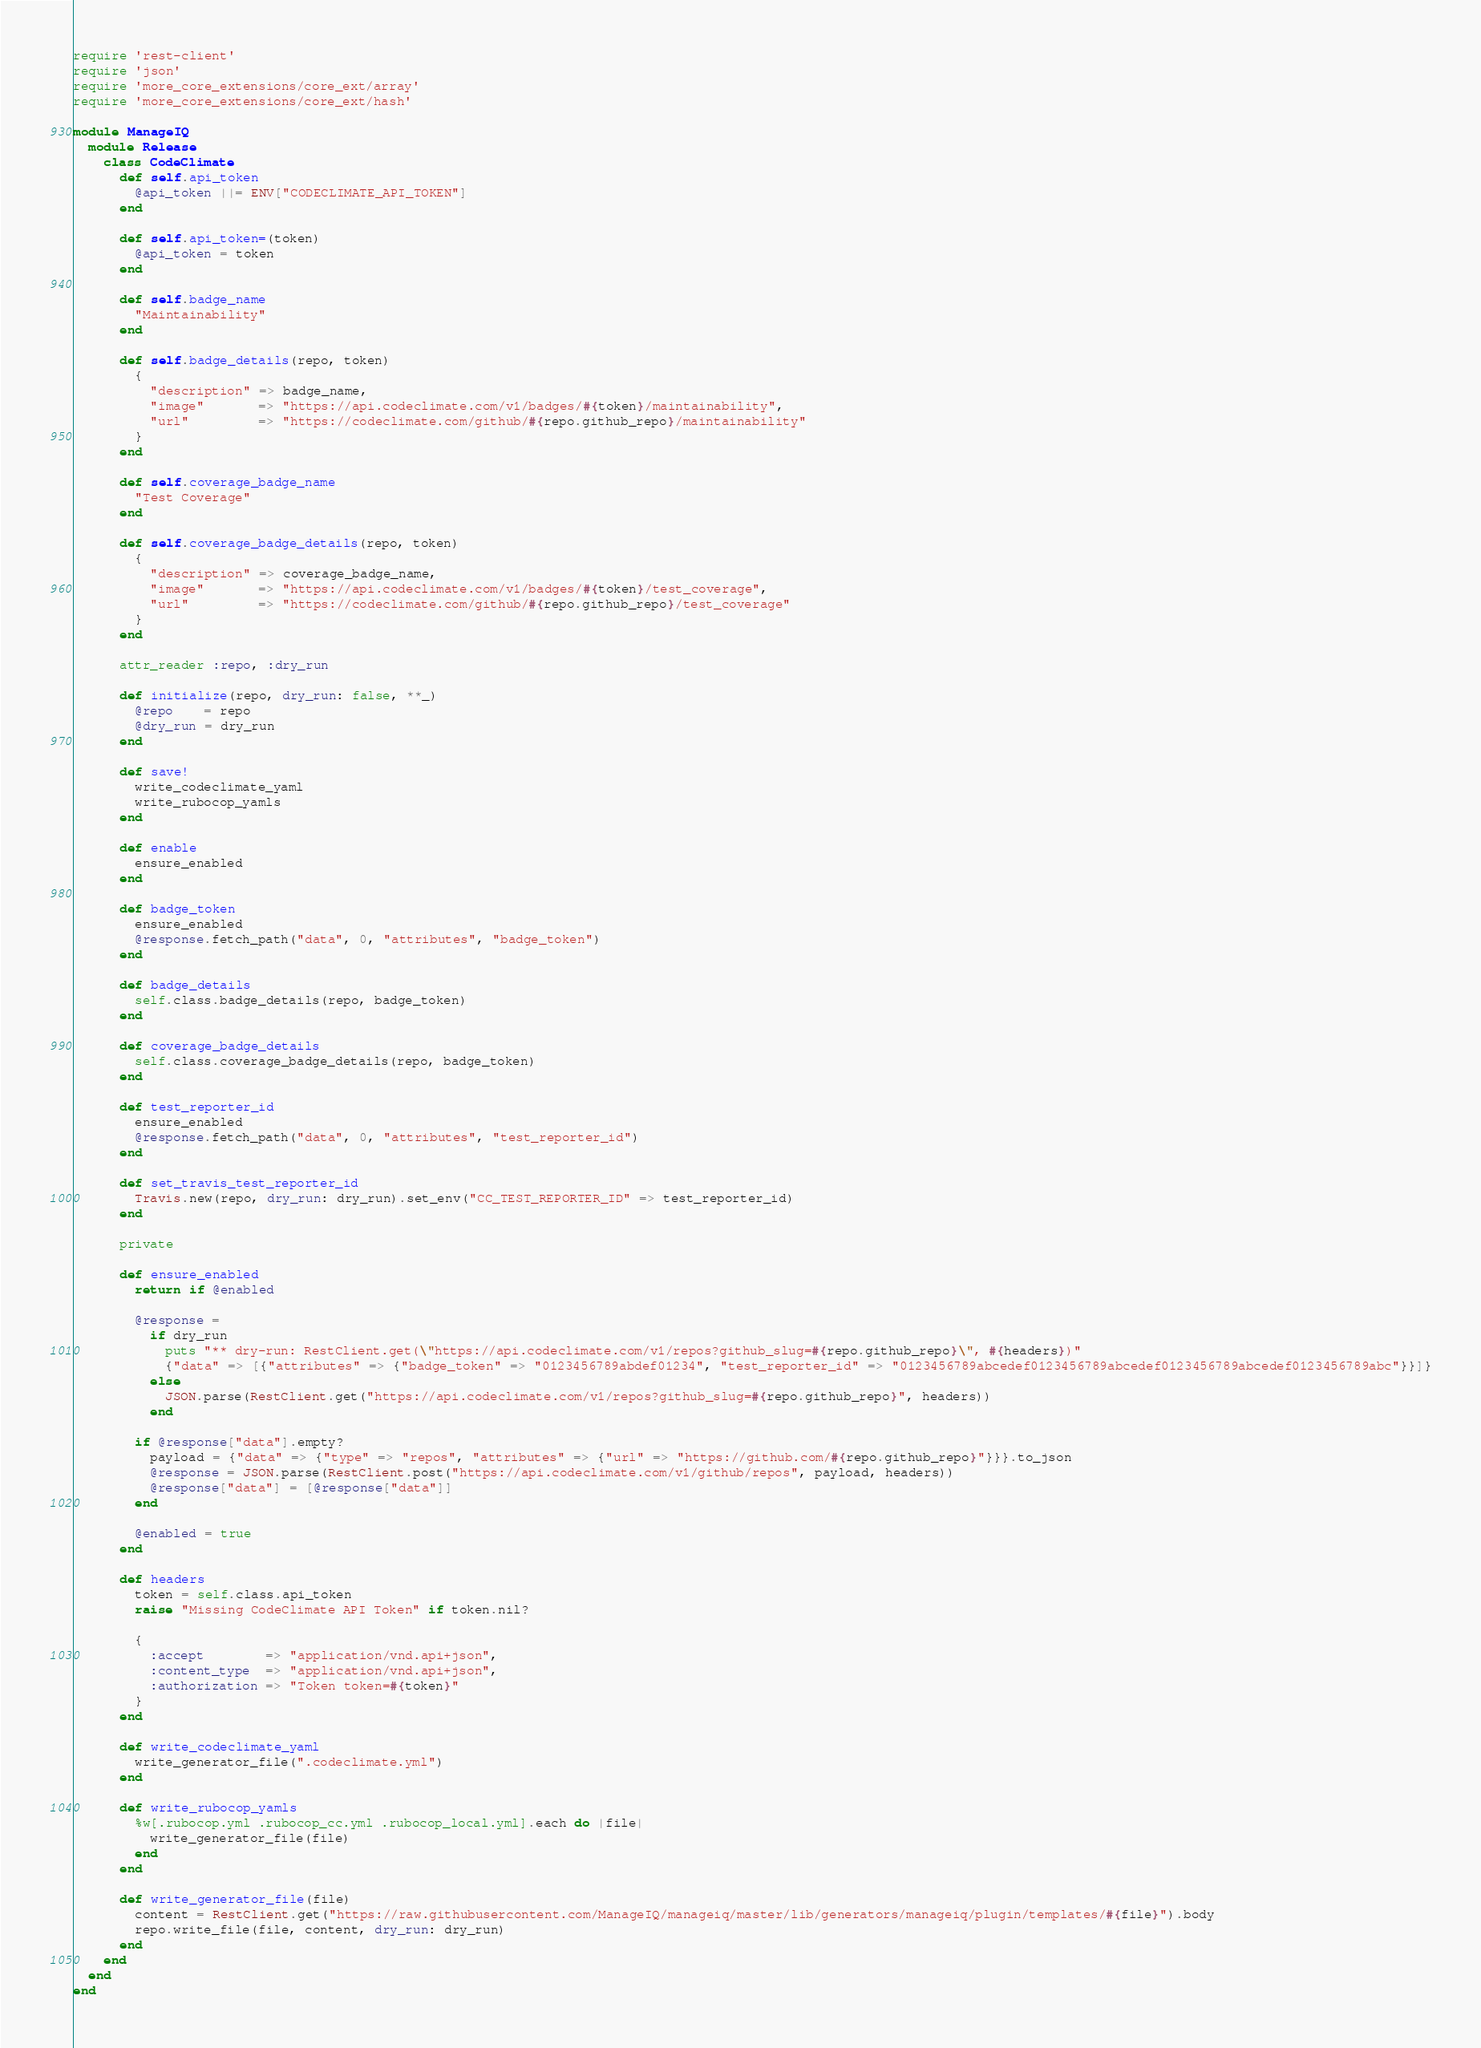Convert code to text. <code><loc_0><loc_0><loc_500><loc_500><_Ruby_>require 'rest-client'
require 'json'
require 'more_core_extensions/core_ext/array'
require 'more_core_extensions/core_ext/hash'

module ManageIQ
  module Release
    class CodeClimate
      def self.api_token
        @api_token ||= ENV["CODECLIMATE_API_TOKEN"]
      end

      def self.api_token=(token)
        @api_token = token
      end

      def self.badge_name
        "Maintainability"
      end

      def self.badge_details(repo, token)
        {
          "description" => badge_name,
          "image"       => "https://api.codeclimate.com/v1/badges/#{token}/maintainability",
          "url"         => "https://codeclimate.com/github/#{repo.github_repo}/maintainability"
        }
      end

      def self.coverage_badge_name
        "Test Coverage"
      end

      def self.coverage_badge_details(repo, token)
        {
          "description" => coverage_badge_name,
          "image"       => "https://api.codeclimate.com/v1/badges/#{token}/test_coverage",
          "url"         => "https://codeclimate.com/github/#{repo.github_repo}/test_coverage"
        }
      end

      attr_reader :repo, :dry_run

      def initialize(repo, dry_run: false, **_)
        @repo    = repo
        @dry_run = dry_run
      end

      def save!
        write_codeclimate_yaml
        write_rubocop_yamls
      end

      def enable
        ensure_enabled
      end

      def badge_token
        ensure_enabled
        @response.fetch_path("data", 0, "attributes", "badge_token")
      end

      def badge_details
        self.class.badge_details(repo, badge_token)
      end

      def coverage_badge_details
        self.class.coverage_badge_details(repo, badge_token)
      end

      def test_reporter_id
        ensure_enabled
        @response.fetch_path("data", 0, "attributes", "test_reporter_id")
      end

      def set_travis_test_reporter_id
        Travis.new(repo, dry_run: dry_run).set_env("CC_TEST_REPORTER_ID" => test_reporter_id)
      end

      private

      def ensure_enabled
        return if @enabled

        @response =
          if dry_run
            puts "** dry-run: RestClient.get(\"https://api.codeclimate.com/v1/repos?github_slug=#{repo.github_repo}\", #{headers})"
            {"data" => [{"attributes" => {"badge_token" => "0123456789abdef01234", "test_reporter_id" => "0123456789abcedef0123456789abcedef0123456789abcedef0123456789abc"}}]}
          else
            JSON.parse(RestClient.get("https://api.codeclimate.com/v1/repos?github_slug=#{repo.github_repo}", headers))
          end

        if @response["data"].empty?
          payload = {"data" => {"type" => "repos", "attributes" => {"url" => "https://github.com/#{repo.github_repo}"}}}.to_json
          @response = JSON.parse(RestClient.post("https://api.codeclimate.com/v1/github/repos", payload, headers))
          @response["data"] = [@response["data"]]
        end

        @enabled = true
      end

      def headers
        token = self.class.api_token
        raise "Missing CodeClimate API Token" if token.nil?

        {
          :accept        => "application/vnd.api+json",
          :content_type  => "application/vnd.api+json",
          :authorization => "Token token=#{token}"
        }
      end

      def write_codeclimate_yaml
        write_generator_file(".codeclimate.yml")
      end

      def write_rubocop_yamls
        %w[.rubocop.yml .rubocop_cc.yml .rubocop_local.yml].each do |file|
          write_generator_file(file)
        end
      end

      def write_generator_file(file)
        content = RestClient.get("https://raw.githubusercontent.com/ManageIQ/manageiq/master/lib/generators/manageiq/plugin/templates/#{file}").body
        repo.write_file(file, content, dry_run: dry_run)
      end
    end
  end
end
</code> 